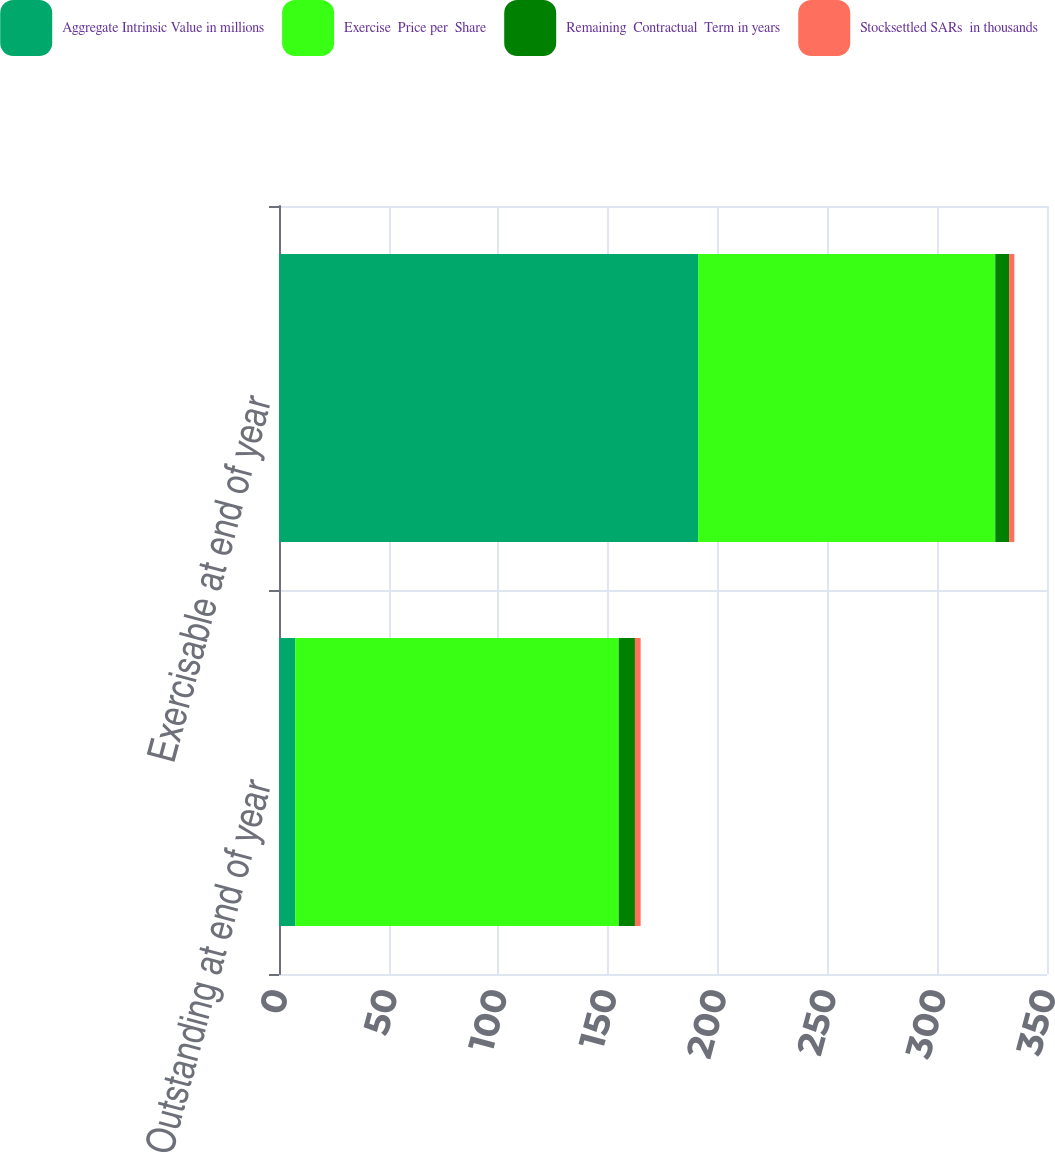Convert chart. <chart><loc_0><loc_0><loc_500><loc_500><stacked_bar_chart><ecel><fcel>Outstanding at end of year<fcel>Exercisable at end of year<nl><fcel>Aggregate Intrinsic Value in millions<fcel>7.4<fcel>191<nl><fcel>Exercise  Price per  Share<fcel>147.41<fcel>135.42<nl><fcel>Remaining  Contractual  Term in years<fcel>7.4<fcel>6.3<nl><fcel>Stocksettled SARs  in thousands<fcel>2.6<fcel>2.4<nl></chart> 